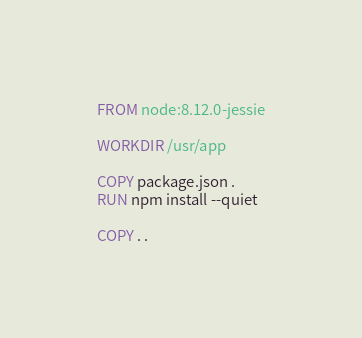<code> <loc_0><loc_0><loc_500><loc_500><_Dockerfile_>FROM node:8.12.0-jessie

WORKDIR /usr/app

COPY package.json .
RUN npm install --quiet

COPY . . 
</code> 